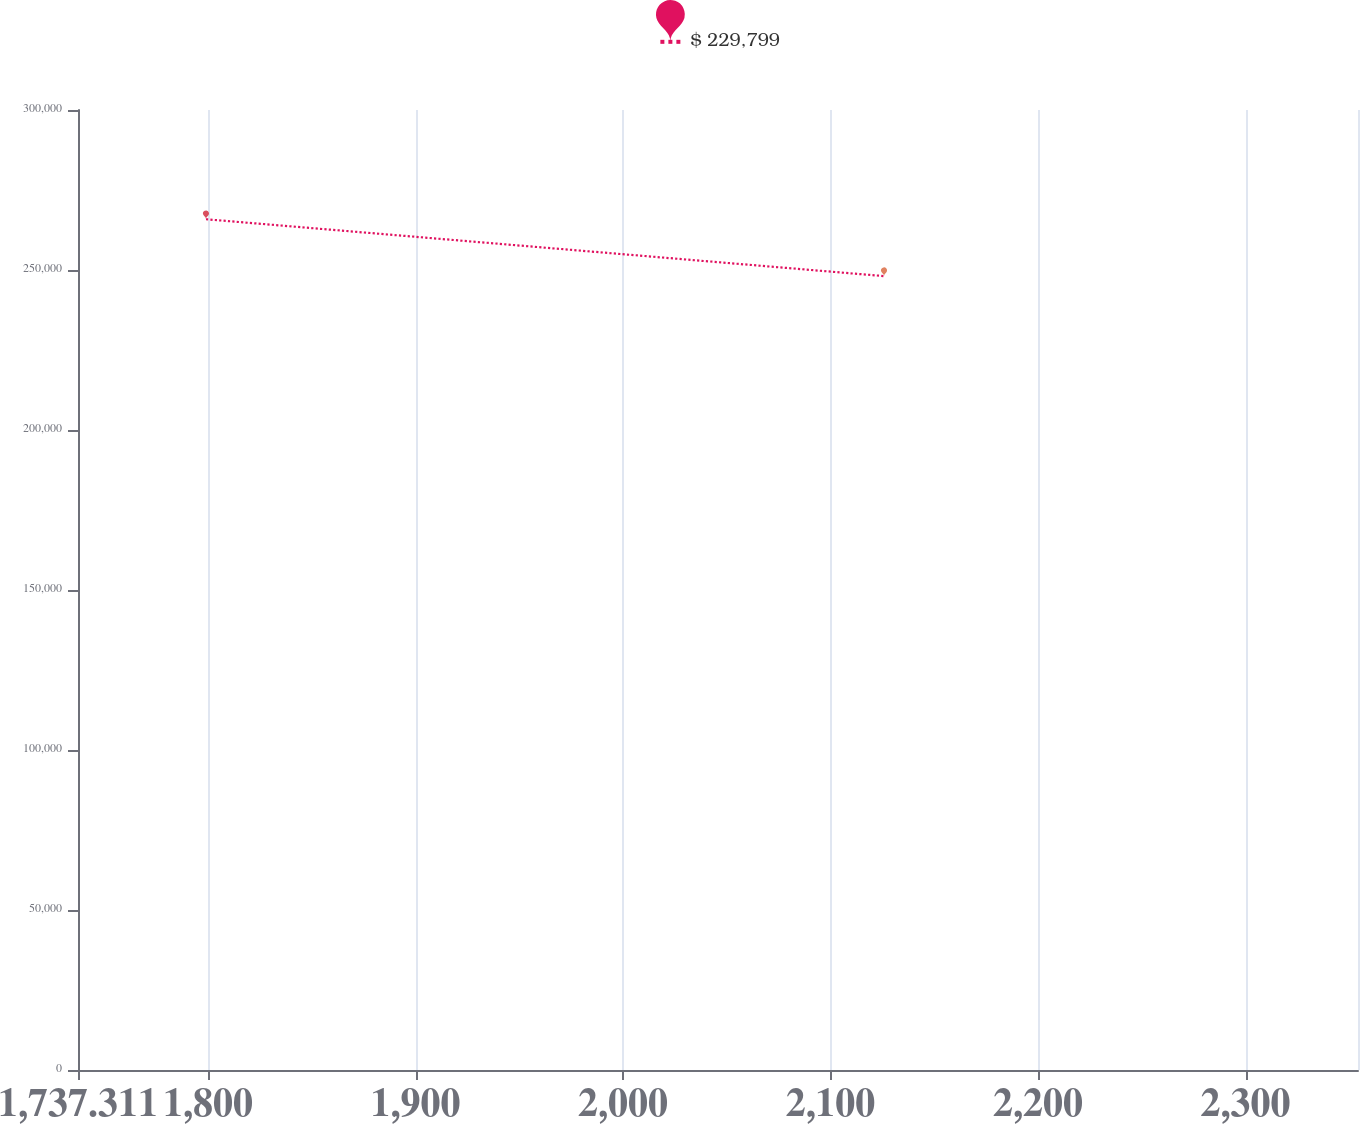Convert chart to OTSL. <chart><loc_0><loc_0><loc_500><loc_500><line_chart><ecel><fcel>$ 229,799<nl><fcel>1799<fcel>265863<nl><fcel>2125.78<fcel>248091<nl><fcel>2355.87<fcel>183311<nl><fcel>2415.89<fcel>209115<nl></chart> 